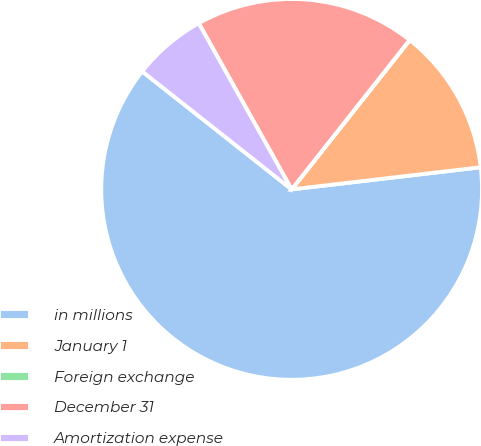<chart> <loc_0><loc_0><loc_500><loc_500><pie_chart><fcel>in millions<fcel>January 1<fcel>Foreign exchange<fcel>December 31<fcel>Amortization expense<nl><fcel>62.49%<fcel>12.5%<fcel>0.01%<fcel>18.75%<fcel>6.25%<nl></chart> 